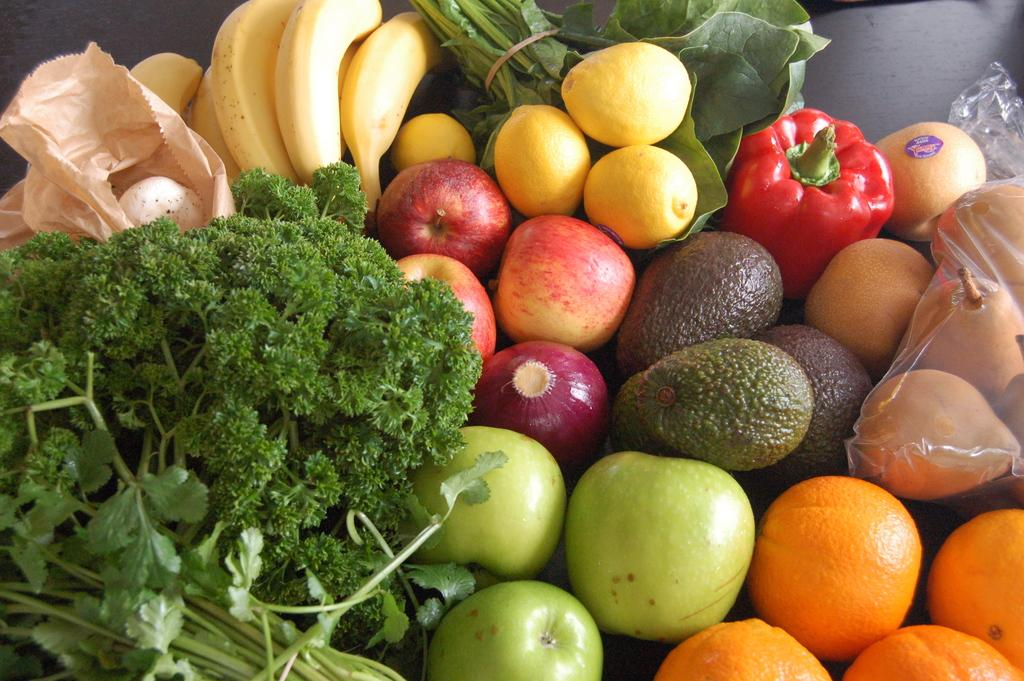What types of food items can be seen in the image? There are fruits, vegetables, and green leafy vegetables in the image. Can you describe the specific types of vegetables in the image? Unfortunately, the specific types of vegetables cannot be identified from the image. What is the food item in a cover in the image? The food item in a cover cannot be identified from the image. What type of cap is the book wearing in the image? There is no book or cap present in the image. Can you tell me the name of the aunt who is holding the vegetables in the image? There is no person, including an aunt, present in the image. 